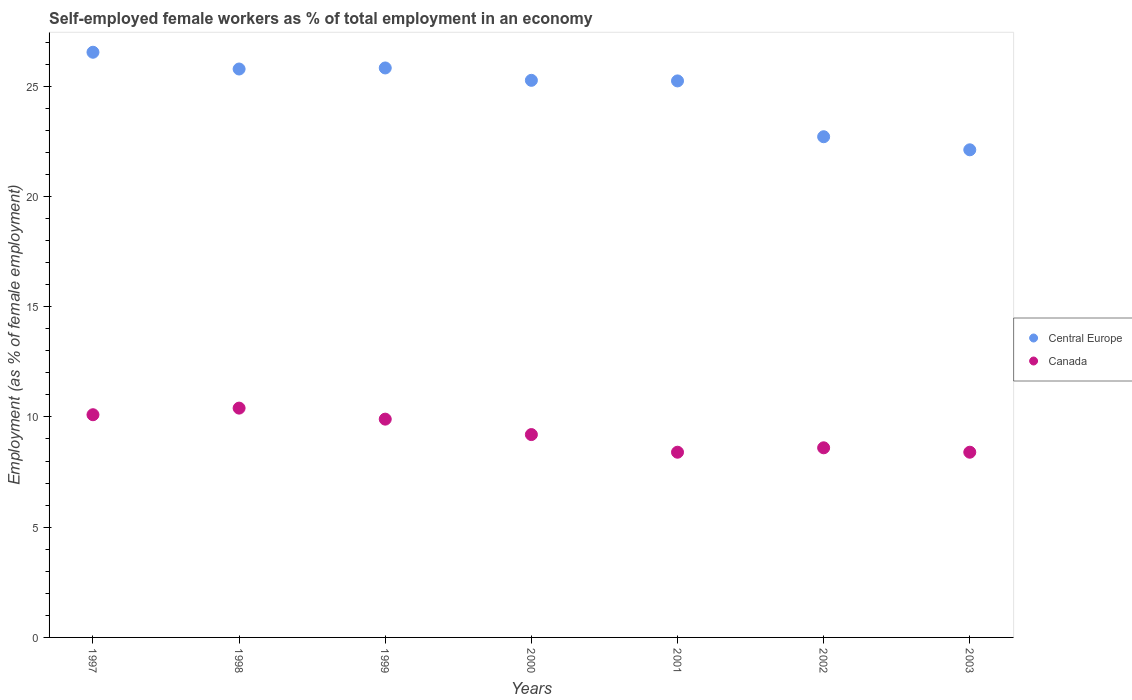How many different coloured dotlines are there?
Ensure brevity in your answer.  2. What is the percentage of self-employed female workers in Canada in 2000?
Offer a terse response. 9.2. Across all years, what is the maximum percentage of self-employed female workers in Central Europe?
Your response must be concise. 26.54. Across all years, what is the minimum percentage of self-employed female workers in Central Europe?
Give a very brief answer. 22.12. In which year was the percentage of self-employed female workers in Canada minimum?
Your response must be concise. 2001. What is the total percentage of self-employed female workers in Central Europe in the graph?
Ensure brevity in your answer.  173.48. What is the difference between the percentage of self-employed female workers in Canada in 2000 and that in 2001?
Provide a succinct answer. 0.8. What is the difference between the percentage of self-employed female workers in Canada in 1998 and the percentage of self-employed female workers in Central Europe in 2001?
Provide a short and direct response. -14.84. What is the average percentage of self-employed female workers in Central Europe per year?
Your response must be concise. 24.78. In the year 1999, what is the difference between the percentage of self-employed female workers in Canada and percentage of self-employed female workers in Central Europe?
Provide a succinct answer. -15.93. In how many years, is the percentage of self-employed female workers in Central Europe greater than 6 %?
Make the answer very short. 7. What is the ratio of the percentage of self-employed female workers in Canada in 1997 to that in 1998?
Your response must be concise. 0.97. Is the percentage of self-employed female workers in Canada in 1998 less than that in 2002?
Provide a succinct answer. No. Is the difference between the percentage of self-employed female workers in Canada in 2000 and 2003 greater than the difference between the percentage of self-employed female workers in Central Europe in 2000 and 2003?
Your response must be concise. No. What is the difference between the highest and the second highest percentage of self-employed female workers in Central Europe?
Your answer should be very brief. 0.71. What is the difference between the highest and the lowest percentage of self-employed female workers in Central Europe?
Provide a succinct answer. 4.42. Does the percentage of self-employed female workers in Canada monotonically increase over the years?
Provide a succinct answer. No. How many years are there in the graph?
Your response must be concise. 7. What is the difference between two consecutive major ticks on the Y-axis?
Make the answer very short. 5. Are the values on the major ticks of Y-axis written in scientific E-notation?
Offer a terse response. No. Does the graph contain grids?
Your answer should be very brief. No. What is the title of the graph?
Provide a succinct answer. Self-employed female workers as % of total employment in an economy. Does "Timor-Leste" appear as one of the legend labels in the graph?
Make the answer very short. No. What is the label or title of the Y-axis?
Provide a short and direct response. Employment (as % of female employment). What is the Employment (as % of female employment) of Central Europe in 1997?
Keep it short and to the point. 26.54. What is the Employment (as % of female employment) in Canada in 1997?
Ensure brevity in your answer.  10.1. What is the Employment (as % of female employment) in Central Europe in 1998?
Provide a succinct answer. 25.78. What is the Employment (as % of female employment) in Canada in 1998?
Give a very brief answer. 10.4. What is the Employment (as % of female employment) of Central Europe in 1999?
Offer a very short reply. 25.83. What is the Employment (as % of female employment) of Canada in 1999?
Offer a terse response. 9.9. What is the Employment (as % of female employment) of Central Europe in 2000?
Your answer should be very brief. 25.27. What is the Employment (as % of female employment) of Canada in 2000?
Your answer should be very brief. 9.2. What is the Employment (as % of female employment) of Central Europe in 2001?
Ensure brevity in your answer.  25.24. What is the Employment (as % of female employment) in Canada in 2001?
Your answer should be very brief. 8.4. What is the Employment (as % of female employment) of Central Europe in 2002?
Give a very brief answer. 22.71. What is the Employment (as % of female employment) in Canada in 2002?
Give a very brief answer. 8.6. What is the Employment (as % of female employment) in Central Europe in 2003?
Provide a short and direct response. 22.12. What is the Employment (as % of female employment) of Canada in 2003?
Ensure brevity in your answer.  8.4. Across all years, what is the maximum Employment (as % of female employment) in Central Europe?
Keep it short and to the point. 26.54. Across all years, what is the maximum Employment (as % of female employment) in Canada?
Give a very brief answer. 10.4. Across all years, what is the minimum Employment (as % of female employment) of Central Europe?
Offer a terse response. 22.12. Across all years, what is the minimum Employment (as % of female employment) in Canada?
Offer a terse response. 8.4. What is the total Employment (as % of female employment) of Central Europe in the graph?
Make the answer very short. 173.48. What is the difference between the Employment (as % of female employment) of Central Europe in 1997 and that in 1998?
Offer a terse response. 0.76. What is the difference between the Employment (as % of female employment) of Central Europe in 1997 and that in 1999?
Offer a terse response. 0.71. What is the difference between the Employment (as % of female employment) of Central Europe in 1997 and that in 2000?
Make the answer very short. 1.27. What is the difference between the Employment (as % of female employment) of Central Europe in 1997 and that in 2001?
Keep it short and to the point. 1.3. What is the difference between the Employment (as % of female employment) of Canada in 1997 and that in 2001?
Offer a very short reply. 1.7. What is the difference between the Employment (as % of female employment) of Central Europe in 1997 and that in 2002?
Your response must be concise. 3.83. What is the difference between the Employment (as % of female employment) in Central Europe in 1997 and that in 2003?
Provide a short and direct response. 4.42. What is the difference between the Employment (as % of female employment) of Canada in 1997 and that in 2003?
Keep it short and to the point. 1.7. What is the difference between the Employment (as % of female employment) of Central Europe in 1998 and that in 1999?
Offer a very short reply. -0.05. What is the difference between the Employment (as % of female employment) in Central Europe in 1998 and that in 2000?
Make the answer very short. 0.51. What is the difference between the Employment (as % of female employment) of Central Europe in 1998 and that in 2001?
Make the answer very short. 0.54. What is the difference between the Employment (as % of female employment) of Canada in 1998 and that in 2001?
Offer a very short reply. 2. What is the difference between the Employment (as % of female employment) of Central Europe in 1998 and that in 2002?
Make the answer very short. 3.07. What is the difference between the Employment (as % of female employment) in Canada in 1998 and that in 2002?
Make the answer very short. 1.8. What is the difference between the Employment (as % of female employment) in Central Europe in 1998 and that in 2003?
Offer a very short reply. 3.66. What is the difference between the Employment (as % of female employment) in Canada in 1998 and that in 2003?
Offer a terse response. 2. What is the difference between the Employment (as % of female employment) of Central Europe in 1999 and that in 2000?
Your answer should be compact. 0.56. What is the difference between the Employment (as % of female employment) of Central Europe in 1999 and that in 2001?
Your answer should be compact. 0.59. What is the difference between the Employment (as % of female employment) in Canada in 1999 and that in 2001?
Your response must be concise. 1.5. What is the difference between the Employment (as % of female employment) in Central Europe in 1999 and that in 2002?
Provide a succinct answer. 3.12. What is the difference between the Employment (as % of female employment) of Central Europe in 1999 and that in 2003?
Your response must be concise. 3.71. What is the difference between the Employment (as % of female employment) of Canada in 1999 and that in 2003?
Provide a succinct answer. 1.5. What is the difference between the Employment (as % of female employment) of Central Europe in 2000 and that in 2001?
Make the answer very short. 0.03. What is the difference between the Employment (as % of female employment) of Central Europe in 2000 and that in 2002?
Your response must be concise. 2.56. What is the difference between the Employment (as % of female employment) in Central Europe in 2000 and that in 2003?
Provide a succinct answer. 3.15. What is the difference between the Employment (as % of female employment) of Canada in 2000 and that in 2003?
Offer a very short reply. 0.8. What is the difference between the Employment (as % of female employment) in Central Europe in 2001 and that in 2002?
Provide a short and direct response. 2.53. What is the difference between the Employment (as % of female employment) of Canada in 2001 and that in 2002?
Your response must be concise. -0.2. What is the difference between the Employment (as % of female employment) of Central Europe in 2001 and that in 2003?
Offer a terse response. 3.12. What is the difference between the Employment (as % of female employment) of Central Europe in 2002 and that in 2003?
Keep it short and to the point. 0.59. What is the difference between the Employment (as % of female employment) in Canada in 2002 and that in 2003?
Make the answer very short. 0.2. What is the difference between the Employment (as % of female employment) in Central Europe in 1997 and the Employment (as % of female employment) in Canada in 1998?
Your response must be concise. 16.14. What is the difference between the Employment (as % of female employment) of Central Europe in 1997 and the Employment (as % of female employment) of Canada in 1999?
Make the answer very short. 16.64. What is the difference between the Employment (as % of female employment) of Central Europe in 1997 and the Employment (as % of female employment) of Canada in 2000?
Your answer should be very brief. 17.34. What is the difference between the Employment (as % of female employment) in Central Europe in 1997 and the Employment (as % of female employment) in Canada in 2001?
Give a very brief answer. 18.14. What is the difference between the Employment (as % of female employment) of Central Europe in 1997 and the Employment (as % of female employment) of Canada in 2002?
Offer a very short reply. 17.94. What is the difference between the Employment (as % of female employment) in Central Europe in 1997 and the Employment (as % of female employment) in Canada in 2003?
Your answer should be very brief. 18.14. What is the difference between the Employment (as % of female employment) in Central Europe in 1998 and the Employment (as % of female employment) in Canada in 1999?
Provide a short and direct response. 15.88. What is the difference between the Employment (as % of female employment) in Central Europe in 1998 and the Employment (as % of female employment) in Canada in 2000?
Your answer should be compact. 16.58. What is the difference between the Employment (as % of female employment) of Central Europe in 1998 and the Employment (as % of female employment) of Canada in 2001?
Your answer should be very brief. 17.38. What is the difference between the Employment (as % of female employment) of Central Europe in 1998 and the Employment (as % of female employment) of Canada in 2002?
Keep it short and to the point. 17.18. What is the difference between the Employment (as % of female employment) of Central Europe in 1998 and the Employment (as % of female employment) of Canada in 2003?
Provide a succinct answer. 17.38. What is the difference between the Employment (as % of female employment) in Central Europe in 1999 and the Employment (as % of female employment) in Canada in 2000?
Provide a succinct answer. 16.63. What is the difference between the Employment (as % of female employment) of Central Europe in 1999 and the Employment (as % of female employment) of Canada in 2001?
Offer a terse response. 17.43. What is the difference between the Employment (as % of female employment) in Central Europe in 1999 and the Employment (as % of female employment) in Canada in 2002?
Make the answer very short. 17.23. What is the difference between the Employment (as % of female employment) of Central Europe in 1999 and the Employment (as % of female employment) of Canada in 2003?
Offer a terse response. 17.43. What is the difference between the Employment (as % of female employment) of Central Europe in 2000 and the Employment (as % of female employment) of Canada in 2001?
Your response must be concise. 16.87. What is the difference between the Employment (as % of female employment) of Central Europe in 2000 and the Employment (as % of female employment) of Canada in 2002?
Ensure brevity in your answer.  16.67. What is the difference between the Employment (as % of female employment) in Central Europe in 2000 and the Employment (as % of female employment) in Canada in 2003?
Your answer should be compact. 16.87. What is the difference between the Employment (as % of female employment) in Central Europe in 2001 and the Employment (as % of female employment) in Canada in 2002?
Your response must be concise. 16.64. What is the difference between the Employment (as % of female employment) in Central Europe in 2001 and the Employment (as % of female employment) in Canada in 2003?
Keep it short and to the point. 16.84. What is the difference between the Employment (as % of female employment) of Central Europe in 2002 and the Employment (as % of female employment) of Canada in 2003?
Give a very brief answer. 14.31. What is the average Employment (as % of female employment) of Central Europe per year?
Your answer should be compact. 24.78. What is the average Employment (as % of female employment) of Canada per year?
Ensure brevity in your answer.  9.29. In the year 1997, what is the difference between the Employment (as % of female employment) of Central Europe and Employment (as % of female employment) of Canada?
Keep it short and to the point. 16.44. In the year 1998, what is the difference between the Employment (as % of female employment) of Central Europe and Employment (as % of female employment) of Canada?
Offer a terse response. 15.38. In the year 1999, what is the difference between the Employment (as % of female employment) in Central Europe and Employment (as % of female employment) in Canada?
Give a very brief answer. 15.93. In the year 2000, what is the difference between the Employment (as % of female employment) of Central Europe and Employment (as % of female employment) of Canada?
Your answer should be very brief. 16.07. In the year 2001, what is the difference between the Employment (as % of female employment) in Central Europe and Employment (as % of female employment) in Canada?
Ensure brevity in your answer.  16.84. In the year 2002, what is the difference between the Employment (as % of female employment) in Central Europe and Employment (as % of female employment) in Canada?
Ensure brevity in your answer.  14.11. In the year 2003, what is the difference between the Employment (as % of female employment) of Central Europe and Employment (as % of female employment) of Canada?
Your answer should be compact. 13.72. What is the ratio of the Employment (as % of female employment) in Central Europe in 1997 to that in 1998?
Your answer should be compact. 1.03. What is the ratio of the Employment (as % of female employment) in Canada in 1997 to that in 1998?
Your response must be concise. 0.97. What is the ratio of the Employment (as % of female employment) in Central Europe in 1997 to that in 1999?
Offer a terse response. 1.03. What is the ratio of the Employment (as % of female employment) in Canada in 1997 to that in 1999?
Your response must be concise. 1.02. What is the ratio of the Employment (as % of female employment) in Central Europe in 1997 to that in 2000?
Your response must be concise. 1.05. What is the ratio of the Employment (as % of female employment) of Canada in 1997 to that in 2000?
Offer a very short reply. 1.1. What is the ratio of the Employment (as % of female employment) of Central Europe in 1997 to that in 2001?
Provide a succinct answer. 1.05. What is the ratio of the Employment (as % of female employment) in Canada in 1997 to that in 2001?
Give a very brief answer. 1.2. What is the ratio of the Employment (as % of female employment) in Central Europe in 1997 to that in 2002?
Provide a succinct answer. 1.17. What is the ratio of the Employment (as % of female employment) in Canada in 1997 to that in 2002?
Offer a terse response. 1.17. What is the ratio of the Employment (as % of female employment) in Central Europe in 1997 to that in 2003?
Your answer should be compact. 1.2. What is the ratio of the Employment (as % of female employment) in Canada in 1997 to that in 2003?
Offer a terse response. 1.2. What is the ratio of the Employment (as % of female employment) in Canada in 1998 to that in 1999?
Your response must be concise. 1.05. What is the ratio of the Employment (as % of female employment) in Central Europe in 1998 to that in 2000?
Offer a terse response. 1.02. What is the ratio of the Employment (as % of female employment) of Canada in 1998 to that in 2000?
Provide a short and direct response. 1.13. What is the ratio of the Employment (as % of female employment) in Central Europe in 1998 to that in 2001?
Provide a succinct answer. 1.02. What is the ratio of the Employment (as % of female employment) of Canada in 1998 to that in 2001?
Your answer should be compact. 1.24. What is the ratio of the Employment (as % of female employment) in Central Europe in 1998 to that in 2002?
Your response must be concise. 1.14. What is the ratio of the Employment (as % of female employment) in Canada in 1998 to that in 2002?
Provide a succinct answer. 1.21. What is the ratio of the Employment (as % of female employment) of Central Europe in 1998 to that in 2003?
Offer a terse response. 1.17. What is the ratio of the Employment (as % of female employment) in Canada in 1998 to that in 2003?
Your response must be concise. 1.24. What is the ratio of the Employment (as % of female employment) of Central Europe in 1999 to that in 2000?
Keep it short and to the point. 1.02. What is the ratio of the Employment (as % of female employment) of Canada in 1999 to that in 2000?
Ensure brevity in your answer.  1.08. What is the ratio of the Employment (as % of female employment) in Central Europe in 1999 to that in 2001?
Your answer should be very brief. 1.02. What is the ratio of the Employment (as % of female employment) of Canada in 1999 to that in 2001?
Give a very brief answer. 1.18. What is the ratio of the Employment (as % of female employment) in Central Europe in 1999 to that in 2002?
Your answer should be compact. 1.14. What is the ratio of the Employment (as % of female employment) of Canada in 1999 to that in 2002?
Your response must be concise. 1.15. What is the ratio of the Employment (as % of female employment) in Central Europe in 1999 to that in 2003?
Provide a short and direct response. 1.17. What is the ratio of the Employment (as % of female employment) of Canada in 1999 to that in 2003?
Provide a succinct answer. 1.18. What is the ratio of the Employment (as % of female employment) of Central Europe in 2000 to that in 2001?
Make the answer very short. 1. What is the ratio of the Employment (as % of female employment) in Canada in 2000 to that in 2001?
Keep it short and to the point. 1.1. What is the ratio of the Employment (as % of female employment) in Central Europe in 2000 to that in 2002?
Your answer should be very brief. 1.11. What is the ratio of the Employment (as % of female employment) in Canada in 2000 to that in 2002?
Keep it short and to the point. 1.07. What is the ratio of the Employment (as % of female employment) in Central Europe in 2000 to that in 2003?
Keep it short and to the point. 1.14. What is the ratio of the Employment (as % of female employment) in Canada in 2000 to that in 2003?
Offer a terse response. 1.1. What is the ratio of the Employment (as % of female employment) in Central Europe in 2001 to that in 2002?
Make the answer very short. 1.11. What is the ratio of the Employment (as % of female employment) of Canada in 2001 to that in 2002?
Offer a terse response. 0.98. What is the ratio of the Employment (as % of female employment) in Central Europe in 2001 to that in 2003?
Offer a very short reply. 1.14. What is the ratio of the Employment (as % of female employment) of Central Europe in 2002 to that in 2003?
Provide a short and direct response. 1.03. What is the ratio of the Employment (as % of female employment) of Canada in 2002 to that in 2003?
Keep it short and to the point. 1.02. What is the difference between the highest and the second highest Employment (as % of female employment) of Central Europe?
Make the answer very short. 0.71. What is the difference between the highest and the lowest Employment (as % of female employment) in Central Europe?
Your answer should be very brief. 4.42. 